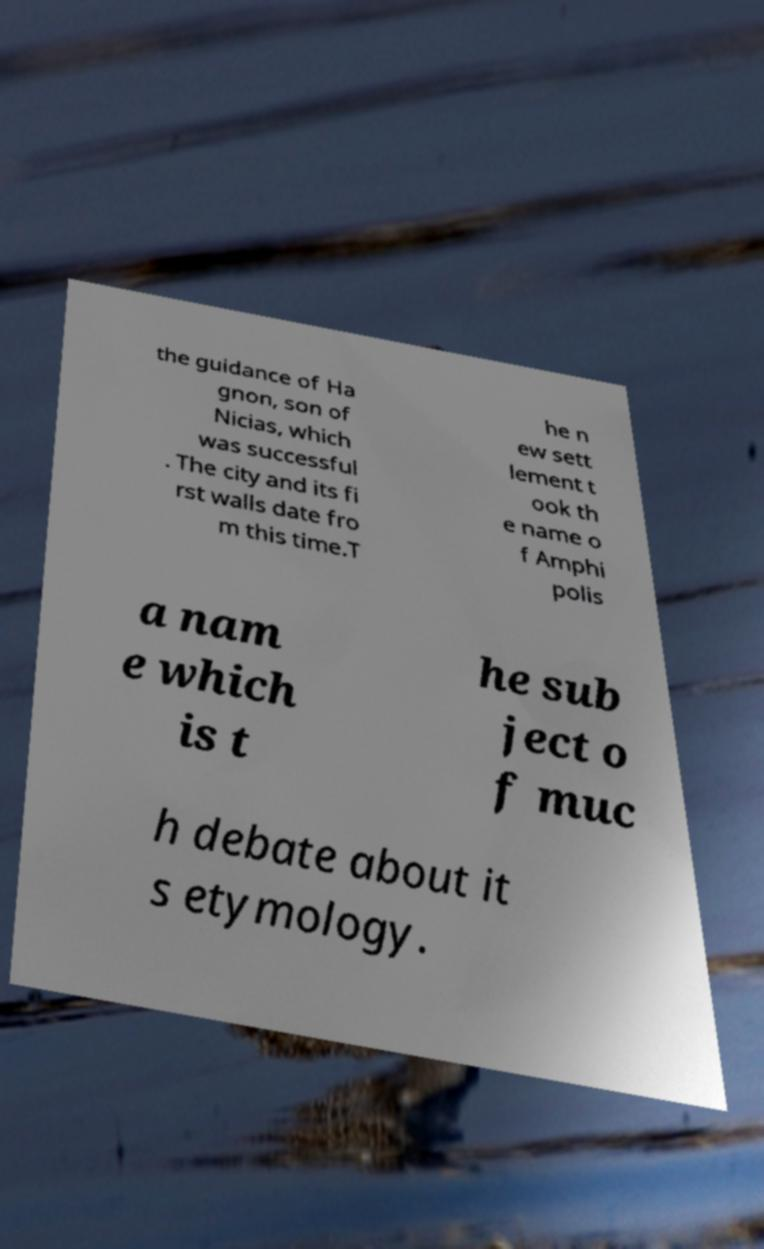Could you extract and type out the text from this image? the guidance of Ha gnon, son of Nicias, which was successful . The city and its fi rst walls date fro m this time.T he n ew sett lement t ook th e name o f Amphi polis a nam e which is t he sub ject o f muc h debate about it s etymology. 